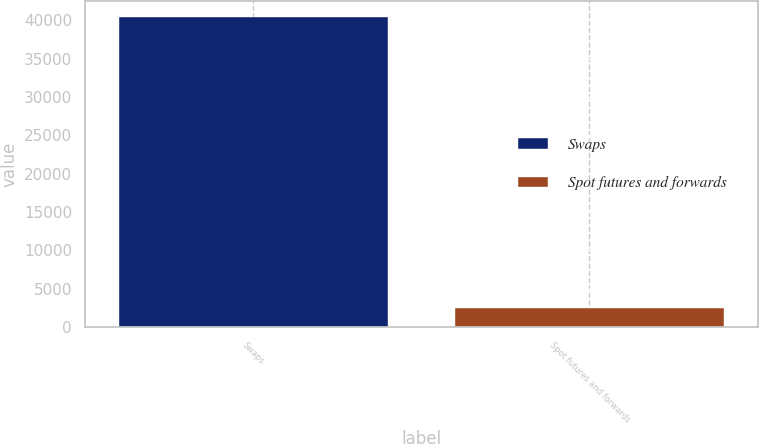<chart> <loc_0><loc_0><loc_500><loc_500><bar_chart><fcel>Swaps<fcel>Spot futures and forwards<nl><fcel>40473.7<fcel>2548.8<nl></chart> 